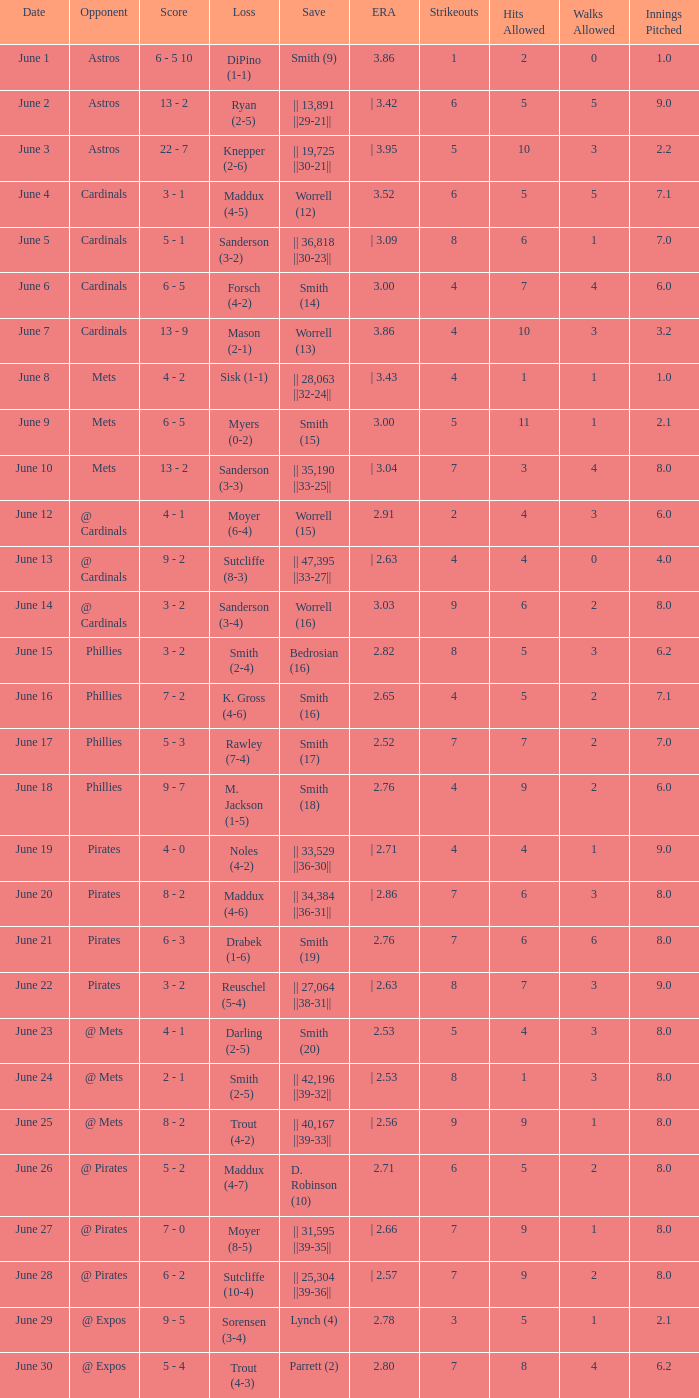The game that has a save of lynch (4) ended with what score? 9 - 5. 